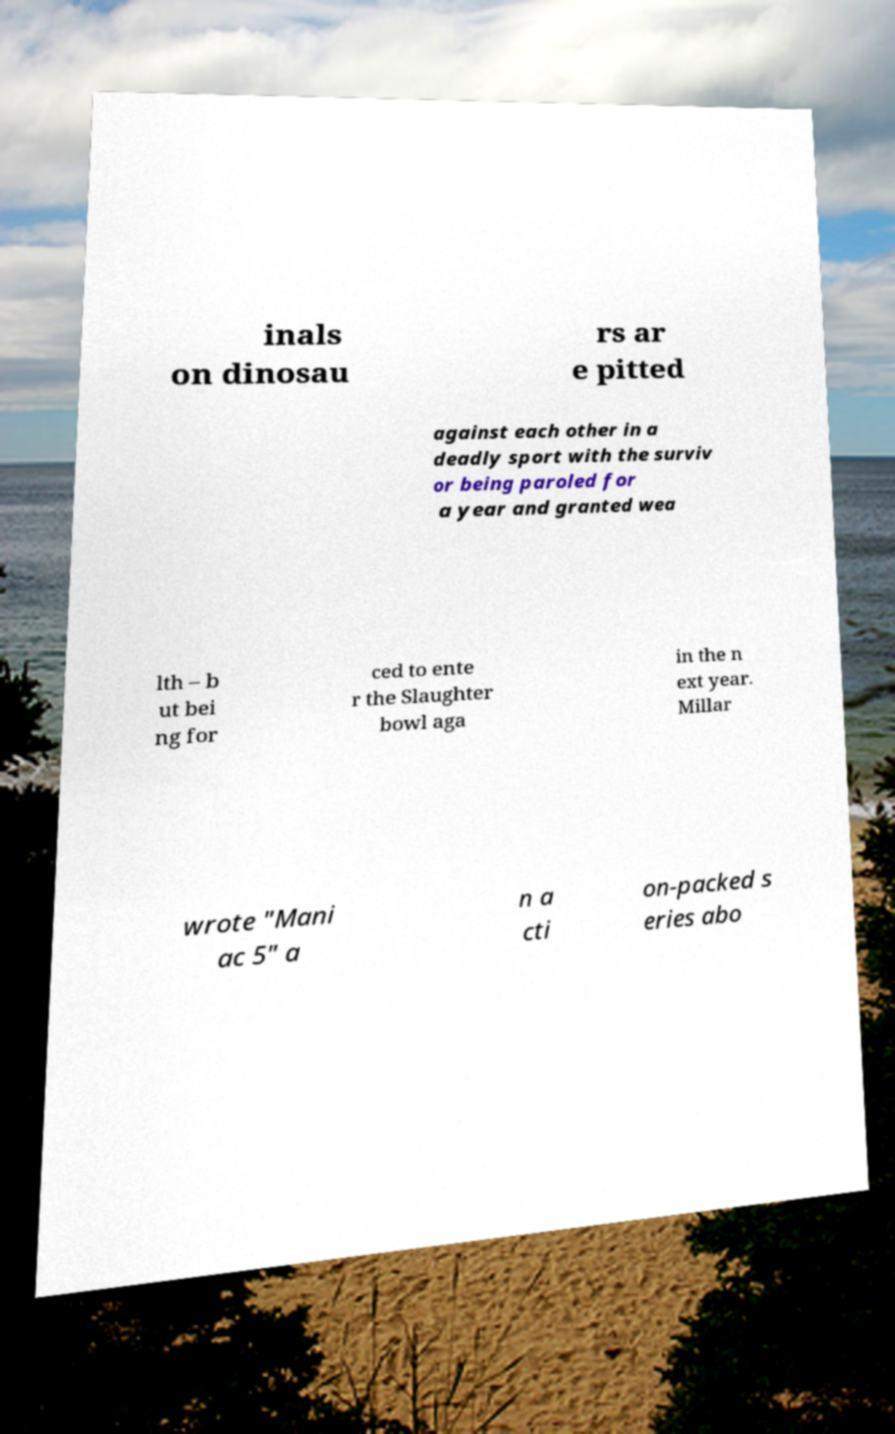Please read and relay the text visible in this image. What does it say? inals on dinosau rs ar e pitted against each other in a deadly sport with the surviv or being paroled for a year and granted wea lth – b ut bei ng for ced to ente r the Slaughter bowl aga in the n ext year. Millar wrote "Mani ac 5" a n a cti on-packed s eries abo 